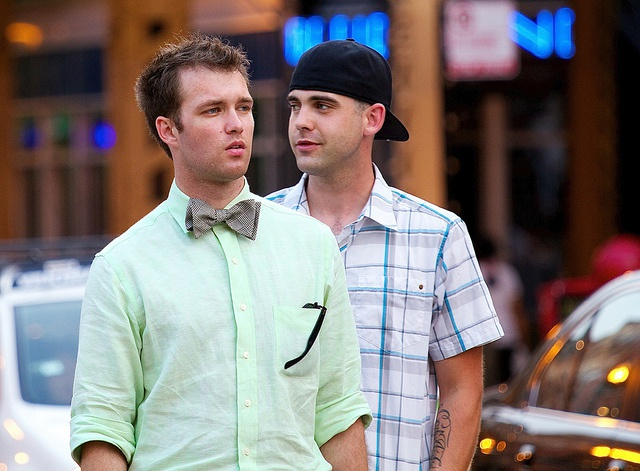Describe the objects in this image and their specific colors. I can see people in maroon, lightblue, beige, and brown tones, people in maroon, lavender, brown, black, and darkgray tones, car in maroon, lightgray, gray, and darkgray tones, car in maroon, lavender, lightblue, gray, and darkgray tones, and tie in maroon, darkgray, gray, black, and lightgray tones in this image. 